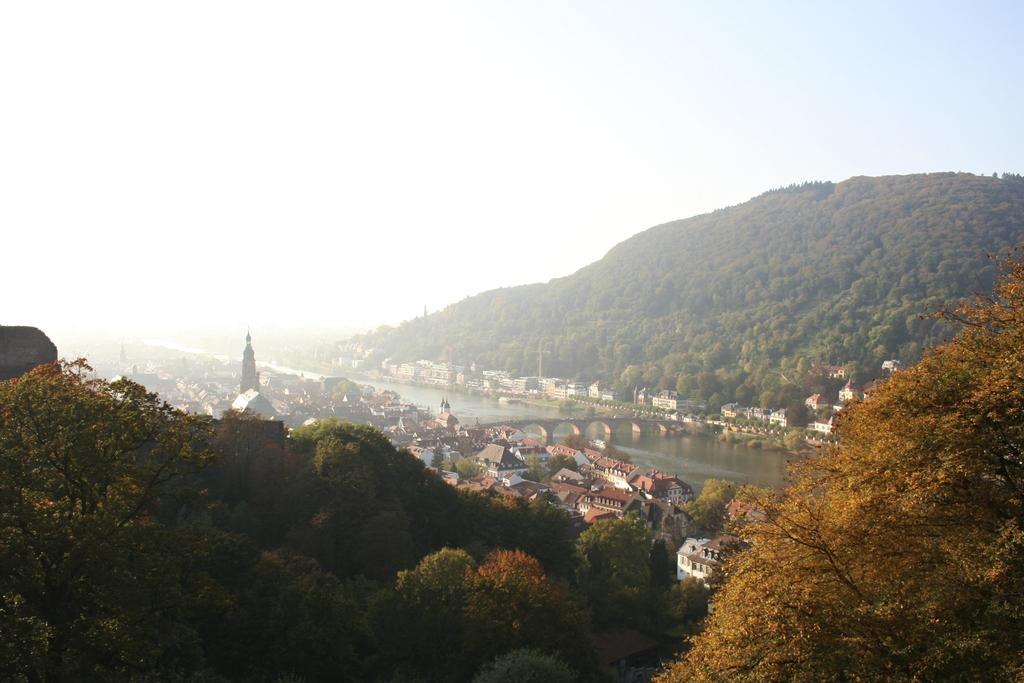What type of natural elements can be seen in the image? There are trees in the image. What type of man-made structures are present in the image? There are buildings and a bridge in the image. What type of geographical feature is visible in the image? There is a mountain in the image. What is visible in the background of the image? The sky is visible in the background of the image. Can you tell me how many giraffes are standing on the bridge in the image? There are no giraffes present in the image; it features trees, buildings, a bridge, a mountain, and the sky. What type of unit is being used to measure the height of the buildings in the image? There is no unit mentioned or visible in the image, and the height of the buildings cannot be determined from the image alone. 